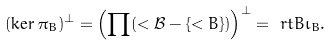<formula> <loc_0><loc_0><loc_500><loc_500>( \ker \pi _ { B } ) ^ { \bot } & = \left ( \prod ( < { \mathcal { B } } - \{ < { B } \} ) \right ) ^ { \bot } = \ r t { B } \iota _ { B } .</formula> 